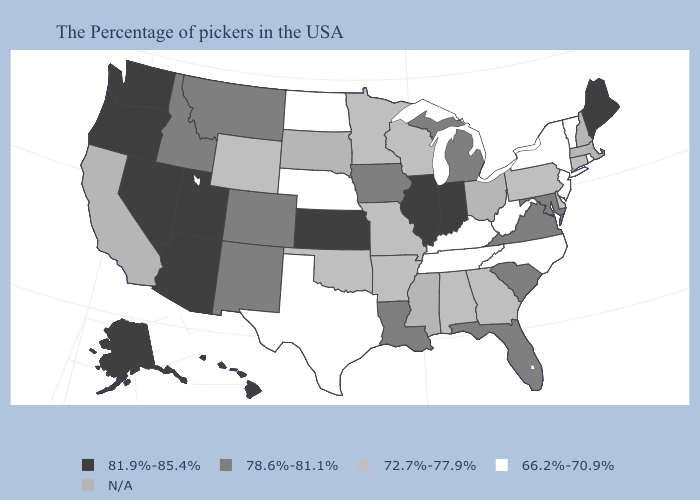What is the value of North Carolina?
Concise answer only. 66.2%-70.9%. Does Utah have the lowest value in the USA?
Short answer required. No. Among the states that border Massachusetts , which have the lowest value?
Concise answer only. Rhode Island, Vermont, New York. Name the states that have a value in the range 81.9%-85.4%?
Keep it brief. Maine, Indiana, Illinois, Kansas, Utah, Arizona, Nevada, Washington, Oregon, Alaska, Hawaii. What is the value of Hawaii?
Short answer required. 81.9%-85.4%. Does the map have missing data?
Concise answer only. Yes. Name the states that have a value in the range 81.9%-85.4%?
Keep it brief. Maine, Indiana, Illinois, Kansas, Utah, Arizona, Nevada, Washington, Oregon, Alaska, Hawaii. What is the value of Connecticut?
Be succinct. 72.7%-77.9%. What is the lowest value in the MidWest?
Concise answer only. 66.2%-70.9%. What is the lowest value in the Northeast?
Answer briefly. 66.2%-70.9%. What is the value of Nevada?
Keep it brief. 81.9%-85.4%. What is the lowest value in the USA?
Concise answer only. 66.2%-70.9%. What is the value of Vermont?
Concise answer only. 66.2%-70.9%. Does Virginia have the highest value in the South?
Be succinct. Yes. 